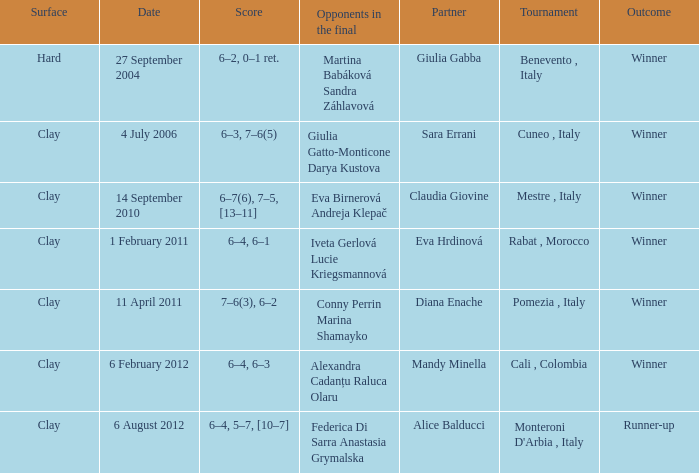Who played on a hard surface? Giulia Gabba. 